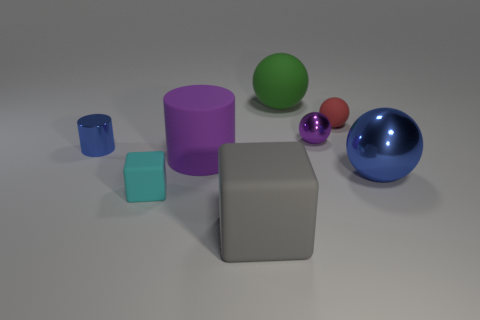Is the tiny shiny ball the same color as the matte cylinder?
Give a very brief answer. Yes. There is a large sphere behind the rubber ball that is to the right of the small purple object; what is it made of?
Your answer should be very brief. Rubber. What is the shape of the large gray thing?
Offer a very short reply. Cube. There is a green object that is the same shape as the tiny red object; what is its material?
Make the answer very short. Rubber. What number of things are the same size as the gray cube?
Offer a terse response. 3. There is a large object that is behind the red object; is there a gray cube that is in front of it?
Make the answer very short. Yes. How many purple objects are small cubes or rubber things?
Offer a very short reply. 1. The large metallic thing is what color?
Your answer should be compact. Blue. There is a red ball that is the same material as the gray thing; what is its size?
Ensure brevity in your answer.  Small. How many other things are the same shape as the big gray matte object?
Keep it short and to the point. 1. 